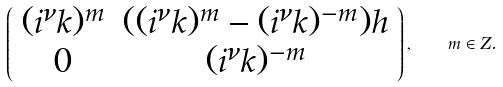<formula> <loc_0><loc_0><loc_500><loc_500>\left ( \begin{array} { c c } ( i ^ { \nu } k ) ^ { m } & ( ( i ^ { \nu } k ) ^ { m } - ( i ^ { \nu } k ) ^ { - m } ) h \\ 0 & ( i ^ { \nu } k ) ^ { - m } \end{array} \right ) , \quad m \in Z .</formula> 